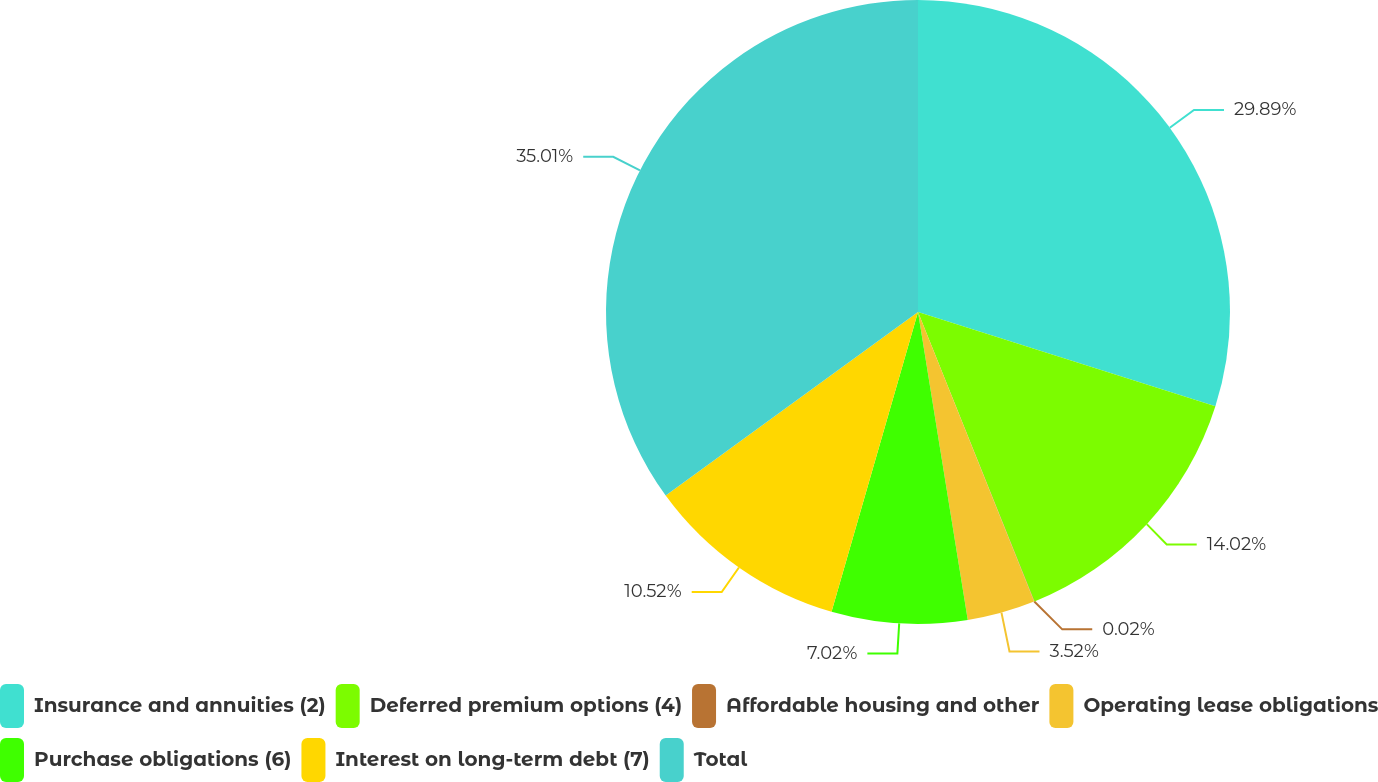Convert chart. <chart><loc_0><loc_0><loc_500><loc_500><pie_chart><fcel>Insurance and annuities (2)<fcel>Deferred premium options (4)<fcel>Affordable housing and other<fcel>Operating lease obligations<fcel>Purchase obligations (6)<fcel>Interest on long-term debt (7)<fcel>Total<nl><fcel>29.89%<fcel>14.02%<fcel>0.02%<fcel>3.52%<fcel>7.02%<fcel>10.52%<fcel>35.01%<nl></chart> 